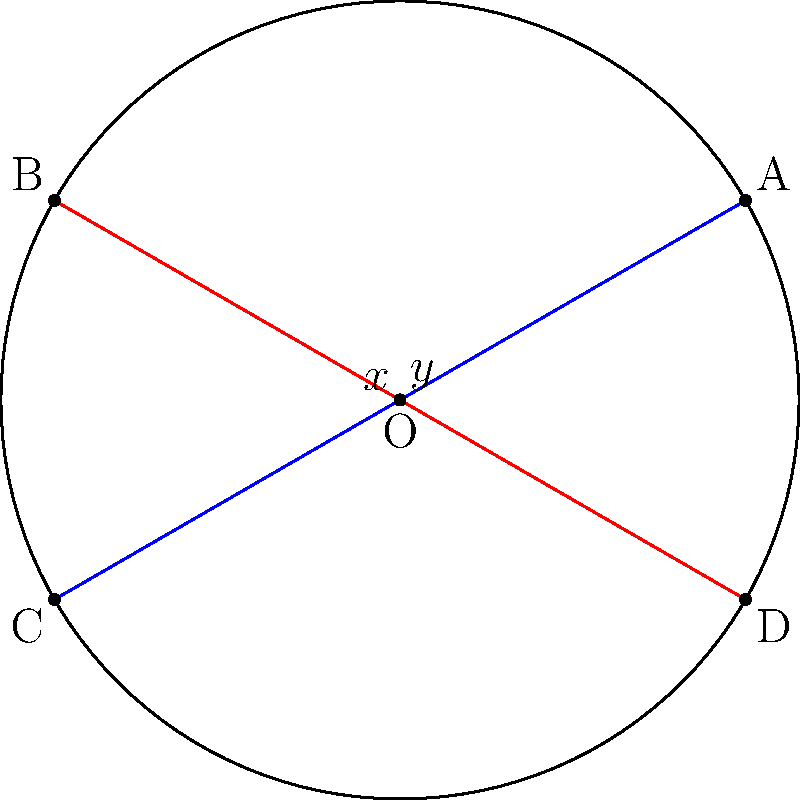In the circle shown above, chords AC and BD intersect at point O. If angle AOB is $60^\circ$ and angle COD is $120^\circ$, what is the value of angle $x + y$? Let's approach this step-by-step:

1) First, recall the theorem about intersecting chords: When two chords intersect inside a circle, the measure of the angle formed is equal to half the sum of the measures of the arcs intercepted by the angle and its vertical angle.

2) In this case, we have two intersecting chords: AC and BD.

3) For angle $x$:
   $x = \frac{1}{2}(\text{arc AB} + \text{arc CD})$

4) For angle $y$:
   $y = \frac{1}{2}(\text{arc BC} + \text{arc DA})$

5) We're given that angle AOB is $60^\circ$ and angle COD is $120^\circ$. In a circle, these central angles are double the inscribed angles that intercept the same arc. So:
   
   arc AB = $60^\circ$
   arc CD = $120^\circ$

6) The sum of all arcs in a circle is $360^\circ$. So:
   
   arc BC + arc DA = $360^\circ - (60^\circ + 120^\circ) = 180^\circ$

7) Now we can calculate $x$ and $y$:
   
   $x = \frac{1}{2}(60^\circ + 120^\circ) = 90^\circ$
   $y = \frac{1}{2}(180^\circ) = 90^\circ$

8) Therefore, $x + y = 90^\circ + 90^\circ = 180^\circ$
Answer: $180^\circ$ 